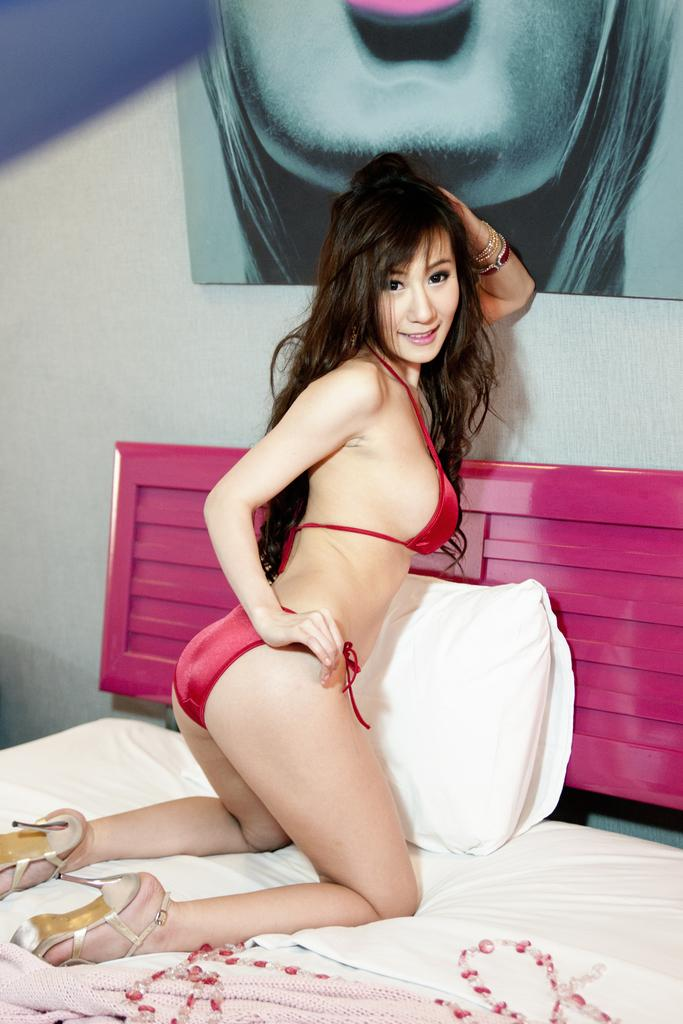Who is in the image? There is a woman in the image. What is the woman doing in the image? The woman is sitting on her knees on the bed. What is the woman's facial expression in the image? The woman is smiling. What can be seen on the bed in the image? There is a pillow on the bed, and the bed is covered with a bed sheet. What is attached to the wall in the image? There is a frame attached to the wall. How many beds are visible in the image? There is only one bed visible in the image, and it is the one the woman is sitting on. What type of town is depicted in the image? There is no town present in the image; it features a woman sitting on a bed. 